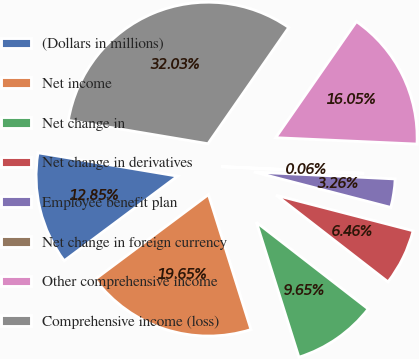Convert chart to OTSL. <chart><loc_0><loc_0><loc_500><loc_500><pie_chart><fcel>(Dollars in millions)<fcel>Net income<fcel>Net change in<fcel>Net change in derivatives<fcel>Employee benefit plan<fcel>Net change in foreign currency<fcel>Other comprehensive income<fcel>Comprehensive income (loss)<nl><fcel>12.85%<fcel>19.65%<fcel>9.65%<fcel>6.46%<fcel>3.26%<fcel>0.06%<fcel>16.05%<fcel>32.03%<nl></chart> 